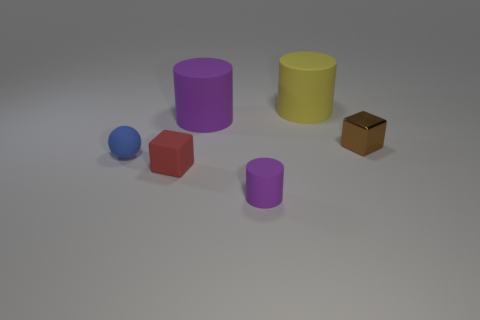What is the size of the other rubber cylinder that is the same color as the tiny matte cylinder?
Provide a succinct answer. Large. What shape is the big rubber thing that is the same color as the small matte cylinder?
Keep it short and to the point. Cylinder. What number of things are cylinders in front of the tiny brown cube or tiny rubber cylinders?
Provide a succinct answer. 1. What is the color of the small rubber object that is the same shape as the small brown metallic thing?
Ensure brevity in your answer.  Red. Is there anything else of the same color as the ball?
Make the answer very short. No. What is the size of the purple rubber thing that is in front of the small blue ball?
Give a very brief answer. Small. Is the color of the small matte cylinder the same as the rubber thing that is to the left of the tiny red rubber thing?
Keep it short and to the point. No. How many other things are there of the same material as the large yellow thing?
Give a very brief answer. 4. Are there more tiny matte objects than blue spheres?
Your response must be concise. Yes. Do the small cube behind the red rubber cube and the tiny rubber ball have the same color?
Offer a terse response. No. 